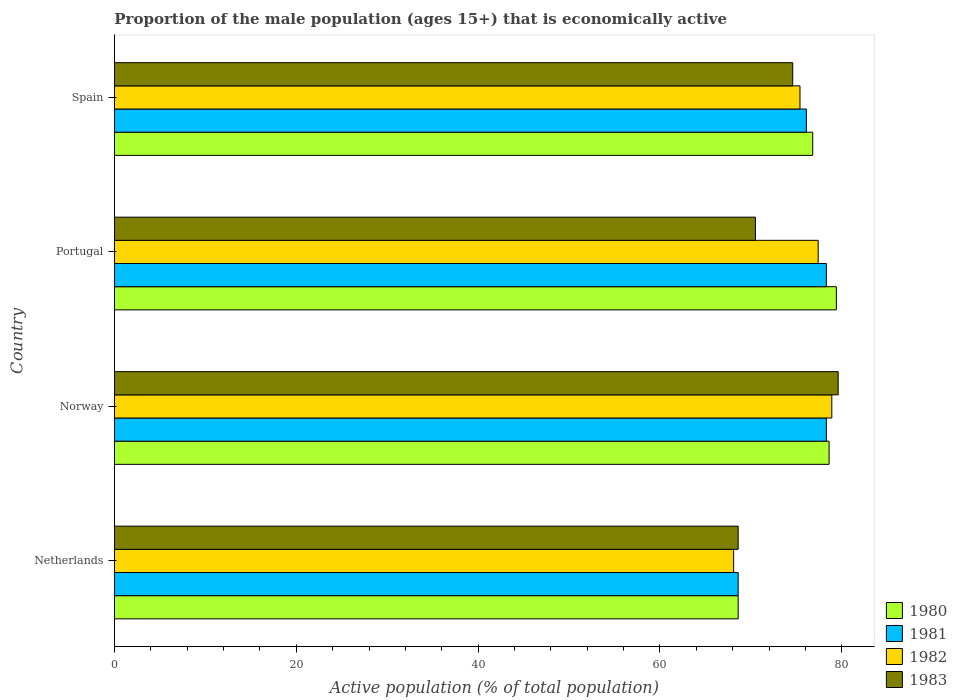Are the number of bars per tick equal to the number of legend labels?
Provide a succinct answer. Yes. How many bars are there on the 2nd tick from the bottom?
Your answer should be compact. 4. What is the proportion of the male population that is economically active in 1980 in Portugal?
Give a very brief answer. 79.4. Across all countries, what is the maximum proportion of the male population that is economically active in 1981?
Your answer should be compact. 78.3. Across all countries, what is the minimum proportion of the male population that is economically active in 1982?
Provide a short and direct response. 68.1. In which country was the proportion of the male population that is economically active in 1983 maximum?
Your response must be concise. Norway. In which country was the proportion of the male population that is economically active in 1980 minimum?
Offer a terse response. Netherlands. What is the total proportion of the male population that is economically active in 1982 in the graph?
Your answer should be compact. 299.8. What is the difference between the proportion of the male population that is economically active in 1983 in Netherlands and that in Portugal?
Offer a very short reply. -1.9. What is the difference between the proportion of the male population that is economically active in 1981 in Norway and the proportion of the male population that is economically active in 1982 in Spain?
Offer a terse response. 2.9. What is the average proportion of the male population that is economically active in 1981 per country?
Your answer should be very brief. 75.33. What is the difference between the proportion of the male population that is economically active in 1983 and proportion of the male population that is economically active in 1982 in Portugal?
Offer a terse response. -6.9. In how many countries, is the proportion of the male population that is economically active in 1981 greater than 64 %?
Offer a terse response. 4. What is the ratio of the proportion of the male population that is economically active in 1980 in Norway to that in Portugal?
Provide a short and direct response. 0.99. Is the proportion of the male population that is economically active in 1982 in Netherlands less than that in Portugal?
Your answer should be very brief. Yes. Is the difference between the proportion of the male population that is economically active in 1983 in Norway and Portugal greater than the difference between the proportion of the male population that is economically active in 1982 in Norway and Portugal?
Provide a succinct answer. Yes. What is the difference between the highest and the second highest proportion of the male population that is economically active in 1980?
Offer a very short reply. 0.8. What is the difference between the highest and the lowest proportion of the male population that is economically active in 1982?
Your answer should be very brief. 10.8. Is the sum of the proportion of the male population that is economically active in 1982 in Norway and Spain greater than the maximum proportion of the male population that is economically active in 1980 across all countries?
Offer a terse response. Yes. Is it the case that in every country, the sum of the proportion of the male population that is economically active in 1982 and proportion of the male population that is economically active in 1980 is greater than the sum of proportion of the male population that is economically active in 1981 and proportion of the male population that is economically active in 1983?
Provide a succinct answer. No. What does the 3rd bar from the top in Portugal represents?
Offer a very short reply. 1981. Is it the case that in every country, the sum of the proportion of the male population that is economically active in 1982 and proportion of the male population that is economically active in 1981 is greater than the proportion of the male population that is economically active in 1983?
Make the answer very short. Yes. How many bars are there?
Keep it short and to the point. 16. How many countries are there in the graph?
Keep it short and to the point. 4. What is the difference between two consecutive major ticks on the X-axis?
Provide a succinct answer. 20. Are the values on the major ticks of X-axis written in scientific E-notation?
Provide a short and direct response. No. Where does the legend appear in the graph?
Provide a succinct answer. Bottom right. How many legend labels are there?
Make the answer very short. 4. How are the legend labels stacked?
Give a very brief answer. Vertical. What is the title of the graph?
Provide a succinct answer. Proportion of the male population (ages 15+) that is economically active. What is the label or title of the X-axis?
Keep it short and to the point. Active population (% of total population). What is the label or title of the Y-axis?
Make the answer very short. Country. What is the Active population (% of total population) of 1980 in Netherlands?
Your answer should be compact. 68.6. What is the Active population (% of total population) in 1981 in Netherlands?
Your answer should be very brief. 68.6. What is the Active population (% of total population) in 1982 in Netherlands?
Offer a very short reply. 68.1. What is the Active population (% of total population) of 1983 in Netherlands?
Ensure brevity in your answer.  68.6. What is the Active population (% of total population) in 1980 in Norway?
Give a very brief answer. 78.6. What is the Active population (% of total population) in 1981 in Norway?
Offer a very short reply. 78.3. What is the Active population (% of total population) of 1982 in Norway?
Your response must be concise. 78.9. What is the Active population (% of total population) in 1983 in Norway?
Provide a succinct answer. 79.6. What is the Active population (% of total population) in 1980 in Portugal?
Offer a very short reply. 79.4. What is the Active population (% of total population) of 1981 in Portugal?
Provide a succinct answer. 78.3. What is the Active population (% of total population) in 1982 in Portugal?
Offer a very short reply. 77.4. What is the Active population (% of total population) in 1983 in Portugal?
Give a very brief answer. 70.5. What is the Active population (% of total population) in 1980 in Spain?
Your answer should be compact. 76.8. What is the Active population (% of total population) of 1981 in Spain?
Ensure brevity in your answer.  76.1. What is the Active population (% of total population) of 1982 in Spain?
Keep it short and to the point. 75.4. What is the Active population (% of total population) in 1983 in Spain?
Ensure brevity in your answer.  74.6. Across all countries, what is the maximum Active population (% of total population) of 1980?
Give a very brief answer. 79.4. Across all countries, what is the maximum Active population (% of total population) of 1981?
Provide a succinct answer. 78.3. Across all countries, what is the maximum Active population (% of total population) in 1982?
Give a very brief answer. 78.9. Across all countries, what is the maximum Active population (% of total population) of 1983?
Offer a very short reply. 79.6. Across all countries, what is the minimum Active population (% of total population) of 1980?
Your response must be concise. 68.6. Across all countries, what is the minimum Active population (% of total population) of 1981?
Offer a terse response. 68.6. Across all countries, what is the minimum Active population (% of total population) in 1982?
Your answer should be compact. 68.1. Across all countries, what is the minimum Active population (% of total population) in 1983?
Ensure brevity in your answer.  68.6. What is the total Active population (% of total population) of 1980 in the graph?
Your answer should be compact. 303.4. What is the total Active population (% of total population) in 1981 in the graph?
Give a very brief answer. 301.3. What is the total Active population (% of total population) in 1982 in the graph?
Offer a terse response. 299.8. What is the total Active population (% of total population) of 1983 in the graph?
Your response must be concise. 293.3. What is the difference between the Active population (% of total population) of 1980 in Netherlands and that in Norway?
Provide a short and direct response. -10. What is the difference between the Active population (% of total population) of 1981 in Netherlands and that in Norway?
Provide a short and direct response. -9.7. What is the difference between the Active population (% of total population) in 1982 in Netherlands and that in Portugal?
Keep it short and to the point. -9.3. What is the difference between the Active population (% of total population) in 1983 in Netherlands and that in Portugal?
Keep it short and to the point. -1.9. What is the difference between the Active population (% of total population) of 1980 in Netherlands and that in Spain?
Make the answer very short. -8.2. What is the difference between the Active population (% of total population) of 1981 in Netherlands and that in Spain?
Keep it short and to the point. -7.5. What is the difference between the Active population (% of total population) in 1980 in Norway and that in Portugal?
Your response must be concise. -0.8. What is the difference between the Active population (% of total population) in 1980 in Norway and that in Spain?
Provide a short and direct response. 1.8. What is the difference between the Active population (% of total population) in 1981 in Norway and that in Spain?
Make the answer very short. 2.2. What is the difference between the Active population (% of total population) in 1982 in Norway and that in Spain?
Make the answer very short. 3.5. What is the difference between the Active population (% of total population) of 1980 in Portugal and that in Spain?
Give a very brief answer. 2.6. What is the difference between the Active population (% of total population) in 1981 in Portugal and that in Spain?
Give a very brief answer. 2.2. What is the difference between the Active population (% of total population) in 1982 in Portugal and that in Spain?
Provide a short and direct response. 2. What is the difference between the Active population (% of total population) of 1980 in Netherlands and the Active population (% of total population) of 1981 in Norway?
Your answer should be compact. -9.7. What is the difference between the Active population (% of total population) in 1980 in Netherlands and the Active population (% of total population) in 1982 in Norway?
Make the answer very short. -10.3. What is the difference between the Active population (% of total population) of 1980 in Netherlands and the Active population (% of total population) of 1983 in Portugal?
Your answer should be compact. -1.9. What is the difference between the Active population (% of total population) of 1980 in Netherlands and the Active population (% of total population) of 1981 in Spain?
Make the answer very short. -7.5. What is the difference between the Active population (% of total population) in 1980 in Netherlands and the Active population (% of total population) in 1982 in Spain?
Offer a terse response. -6.8. What is the difference between the Active population (% of total population) in 1980 in Netherlands and the Active population (% of total population) in 1983 in Spain?
Provide a short and direct response. -6. What is the difference between the Active population (% of total population) of 1981 in Netherlands and the Active population (% of total population) of 1982 in Spain?
Your answer should be compact. -6.8. What is the difference between the Active population (% of total population) in 1980 in Norway and the Active population (% of total population) in 1981 in Portugal?
Your answer should be compact. 0.3. What is the difference between the Active population (% of total population) in 1981 in Norway and the Active population (% of total population) in 1982 in Portugal?
Your answer should be very brief. 0.9. What is the difference between the Active population (% of total population) of 1980 in Norway and the Active population (% of total population) of 1982 in Spain?
Keep it short and to the point. 3.2. What is the difference between the Active population (% of total population) in 1981 in Norway and the Active population (% of total population) in 1983 in Spain?
Keep it short and to the point. 3.7. What is the difference between the Active population (% of total population) in 1980 in Portugal and the Active population (% of total population) in 1981 in Spain?
Offer a terse response. 3.3. What is the difference between the Active population (% of total population) of 1980 in Portugal and the Active population (% of total population) of 1983 in Spain?
Your answer should be compact. 4.8. What is the difference between the Active population (% of total population) of 1982 in Portugal and the Active population (% of total population) of 1983 in Spain?
Give a very brief answer. 2.8. What is the average Active population (% of total population) in 1980 per country?
Ensure brevity in your answer.  75.85. What is the average Active population (% of total population) in 1981 per country?
Give a very brief answer. 75.33. What is the average Active population (% of total population) in 1982 per country?
Provide a short and direct response. 74.95. What is the average Active population (% of total population) in 1983 per country?
Your answer should be compact. 73.33. What is the difference between the Active population (% of total population) in 1981 and Active population (% of total population) in 1982 in Netherlands?
Ensure brevity in your answer.  0.5. What is the difference between the Active population (% of total population) of 1981 and Active population (% of total population) of 1983 in Netherlands?
Your answer should be compact. 0. What is the difference between the Active population (% of total population) in 1980 and Active population (% of total population) in 1982 in Norway?
Offer a terse response. -0.3. What is the difference between the Active population (% of total population) of 1980 and Active population (% of total population) of 1983 in Norway?
Your answer should be compact. -1. What is the difference between the Active population (% of total population) of 1980 and Active population (% of total population) of 1981 in Portugal?
Provide a succinct answer. 1.1. What is the difference between the Active population (% of total population) in 1980 and Active population (% of total population) in 1983 in Portugal?
Offer a terse response. 8.9. What is the difference between the Active population (% of total population) of 1981 and Active population (% of total population) of 1982 in Portugal?
Your answer should be very brief. 0.9. What is the difference between the Active population (% of total population) in 1981 and Active population (% of total population) in 1983 in Portugal?
Offer a terse response. 7.8. What is the difference between the Active population (% of total population) of 1982 and Active population (% of total population) of 1983 in Portugal?
Ensure brevity in your answer.  6.9. What is the difference between the Active population (% of total population) of 1980 and Active population (% of total population) of 1981 in Spain?
Ensure brevity in your answer.  0.7. What is the difference between the Active population (% of total population) of 1980 and Active population (% of total population) of 1982 in Spain?
Your response must be concise. 1.4. What is the difference between the Active population (% of total population) in 1980 and Active population (% of total population) in 1983 in Spain?
Keep it short and to the point. 2.2. What is the ratio of the Active population (% of total population) in 1980 in Netherlands to that in Norway?
Ensure brevity in your answer.  0.87. What is the ratio of the Active population (% of total population) of 1981 in Netherlands to that in Norway?
Make the answer very short. 0.88. What is the ratio of the Active population (% of total population) in 1982 in Netherlands to that in Norway?
Offer a terse response. 0.86. What is the ratio of the Active population (% of total population) in 1983 in Netherlands to that in Norway?
Provide a short and direct response. 0.86. What is the ratio of the Active population (% of total population) in 1980 in Netherlands to that in Portugal?
Give a very brief answer. 0.86. What is the ratio of the Active population (% of total population) in 1981 in Netherlands to that in Portugal?
Offer a terse response. 0.88. What is the ratio of the Active population (% of total population) in 1982 in Netherlands to that in Portugal?
Your answer should be compact. 0.88. What is the ratio of the Active population (% of total population) in 1980 in Netherlands to that in Spain?
Ensure brevity in your answer.  0.89. What is the ratio of the Active population (% of total population) in 1981 in Netherlands to that in Spain?
Your answer should be compact. 0.9. What is the ratio of the Active population (% of total population) in 1982 in Netherlands to that in Spain?
Offer a very short reply. 0.9. What is the ratio of the Active population (% of total population) of 1983 in Netherlands to that in Spain?
Offer a terse response. 0.92. What is the ratio of the Active population (% of total population) of 1980 in Norway to that in Portugal?
Provide a succinct answer. 0.99. What is the ratio of the Active population (% of total population) in 1981 in Norway to that in Portugal?
Give a very brief answer. 1. What is the ratio of the Active population (% of total population) in 1982 in Norway to that in Portugal?
Offer a very short reply. 1.02. What is the ratio of the Active population (% of total population) of 1983 in Norway to that in Portugal?
Offer a terse response. 1.13. What is the ratio of the Active population (% of total population) in 1980 in Norway to that in Spain?
Make the answer very short. 1.02. What is the ratio of the Active population (% of total population) in 1981 in Norway to that in Spain?
Ensure brevity in your answer.  1.03. What is the ratio of the Active population (% of total population) of 1982 in Norway to that in Spain?
Offer a terse response. 1.05. What is the ratio of the Active population (% of total population) of 1983 in Norway to that in Spain?
Offer a terse response. 1.07. What is the ratio of the Active population (% of total population) in 1980 in Portugal to that in Spain?
Ensure brevity in your answer.  1.03. What is the ratio of the Active population (% of total population) in 1981 in Portugal to that in Spain?
Give a very brief answer. 1.03. What is the ratio of the Active population (% of total population) of 1982 in Portugal to that in Spain?
Your answer should be compact. 1.03. What is the ratio of the Active population (% of total population) of 1983 in Portugal to that in Spain?
Make the answer very short. 0.94. What is the difference between the highest and the second highest Active population (% of total population) of 1981?
Give a very brief answer. 0. What is the difference between the highest and the second highest Active population (% of total population) of 1983?
Provide a succinct answer. 5. What is the difference between the highest and the lowest Active population (% of total population) in 1982?
Your answer should be compact. 10.8. 